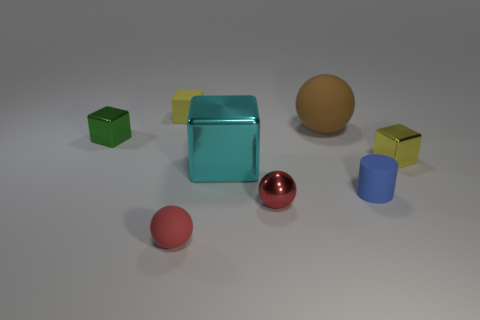How many objects are there in the image, and can you describe them? There are six objects in the image. Starting from the left, there's a small green cube, a medium-sized cyan cube that's partially translucent, a small yellow cube, a large brown sphere, a small shiny red sphere, and a medium-sized blue cylinder. 